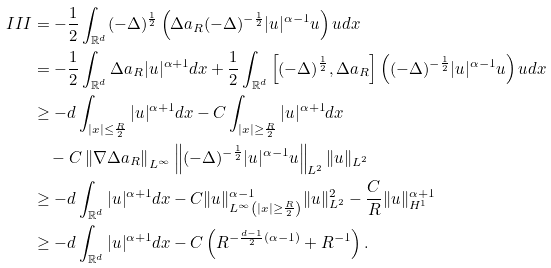Convert formula to latex. <formula><loc_0><loc_0><loc_500><loc_500>I I I & = - \frac { 1 } { 2 } \int _ { \mathbb { R } ^ { d } } ( - \Delta ) ^ { \frac { 1 } { 2 } } \left ( \Delta a _ { R } ( - \Delta ) ^ { - \frac { 1 } { 2 } } | u | ^ { \alpha - 1 } u \right ) u d x \\ & = - \frac { 1 } { 2 } \int _ { \mathbb { R } ^ { d } } \Delta a _ { R } | u | ^ { \alpha + 1 } d x + \frac { 1 } { 2 } \int _ { \mathbb { R } ^ { d } } \left [ ( - \Delta ) ^ { \frac { 1 } { 2 } } , \Delta a _ { R } \right ] \left ( ( - \Delta ) ^ { - \frac { 1 } { 2 } } | u | ^ { \alpha - 1 } u \right ) u d x \\ & \geq - d \int _ { | x | \leq \frac { R } { 2 } } | u | ^ { \alpha + 1 } d x - C \int _ { | x | \geq \frac { R } { 2 } } | u | ^ { \alpha + 1 } d x \\ & \quad - C \left \| \nabla \Delta a _ { R } \right \| _ { L ^ { \infty } } \left \| ( - \Delta ) ^ { - \frac { 1 } { 2 } } | u | ^ { \alpha - 1 } u \right \| _ { L ^ { 2 } } \| u \| _ { L ^ { 2 } } \\ & \geq - d \int _ { \mathbb { R } ^ { d } } | u | ^ { \alpha + 1 } d x - C \| u \| _ { L ^ { \infty } \left ( | x | \geq \frac { R } { 2 } \right ) } ^ { \alpha - 1 } \| u \| _ { L ^ { 2 } } ^ { 2 } - \frac { C } { R } \| u \| _ { H ^ { 1 } } ^ { \alpha + 1 } \\ & \geq - d \int _ { \mathbb { R } ^ { d } } | u | ^ { \alpha + 1 } d x - C \left ( R ^ { - \frac { d - 1 } { 2 } ( \alpha - 1 ) } + R ^ { - 1 } \right ) .</formula> 